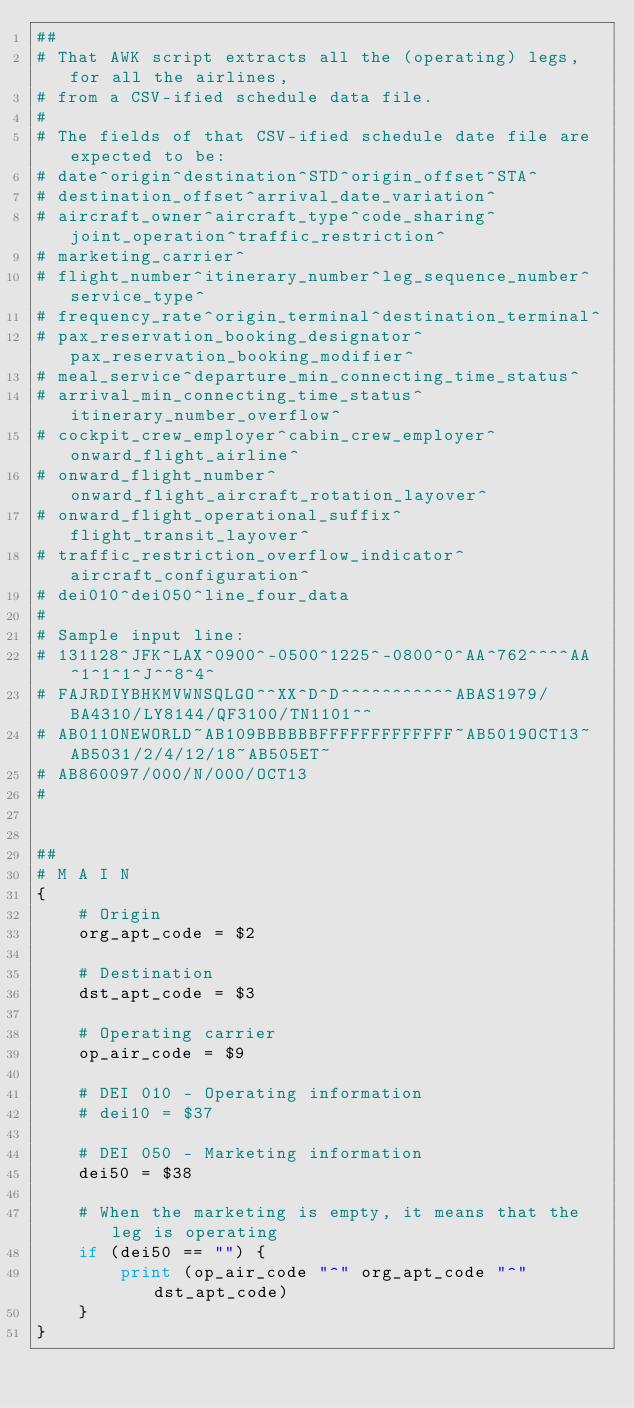Convert code to text. <code><loc_0><loc_0><loc_500><loc_500><_Awk_>##
# That AWK script extracts all the (operating) legs, for all the airlines,
# from a CSV-ified schedule data file.
#
# The fields of that CSV-ified schedule date file are expected to be:
# date^origin^destination^STD^origin_offset^STA^
# destination_offset^arrival_date_variation^
# aircraft_owner^aircraft_type^code_sharing^joint_operation^traffic_restriction^
# marketing_carrier^
# flight_number^itinerary_number^leg_sequence_number^service_type^
# frequency_rate^origin_terminal^destination_terminal^
# pax_reservation_booking_designator^pax_reservation_booking_modifier^
# meal_service^departure_min_connecting_time_status^
# arrival_min_connecting_time_status^itinerary_number_overflow^
# cockpit_crew_employer^cabin_crew_employer^onward_flight_airline^
# onward_flight_number^onward_flight_aircraft_rotation_layover^
# onward_flight_operational_suffix^flight_transit_layover^
# traffic_restriction_overflow_indicator^aircraft_configuration^
# dei010^dei050^line_four_data
#
# Sample input line:
# 131128^JFK^LAX^0900^-0500^1225^-0800^0^AA^762^^^^AA^1^1^1^J^^8^4^
# FAJRDIYBHKMVWNSQLGO^^XX^D^D^^^^^^^^^^^ABAS1979/BA4310/LY8144/QF3100/TN1101^^
# AB011ONEWORLD~AB109BBBBBBFFFFFFFFFFFFF~AB5019OCT13~AB5031/2/4/12/18~AB505ET~
# AB860097/000/N/000/OCT13
#


##
# M A I N
{
	# Origin
	org_apt_code = $2

	# Destination
	dst_apt_code = $3

	# Operating carrier
	op_air_code = $9

	# DEI 010 - Operating information
	# dei10 = $37

	# DEI 050 - Marketing information
	dei50 = $38

	# When the marketing is empty, it means that the leg is operating
	if (dei50 == "") {
		print (op_air_code "^" org_apt_code "^" dst_apt_code)
	}
}
</code> 